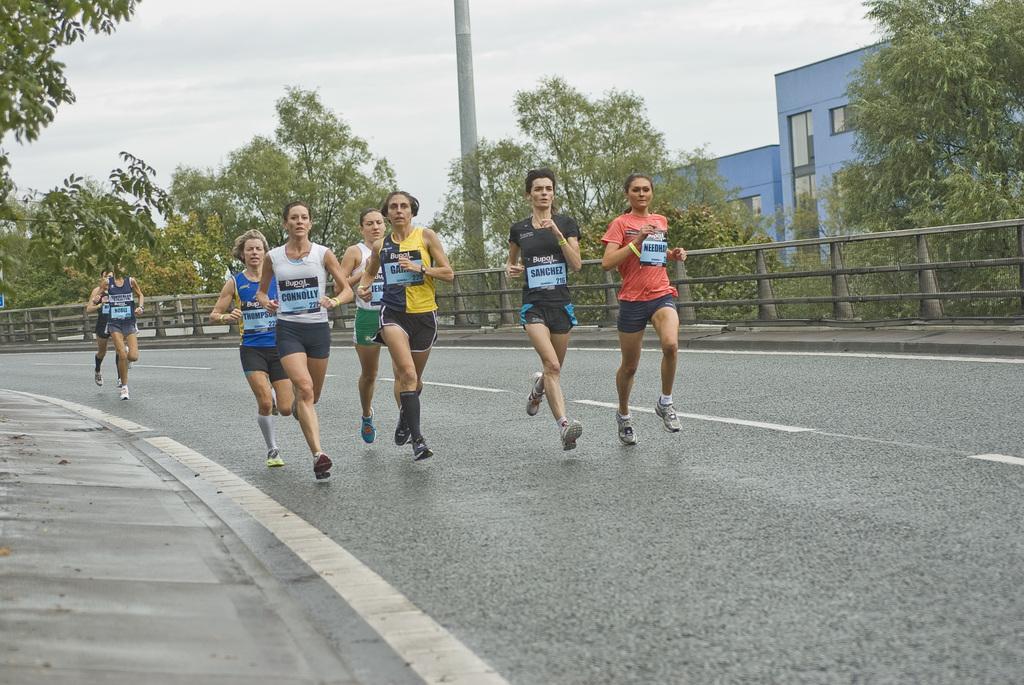Please provide a concise description of this image. In this image I can see a group of people running. They are wearing different color dress. Back Side I can see trees,fencing and a pole. I can see a blue color building and glass windows. The sky is in white and blue color. 